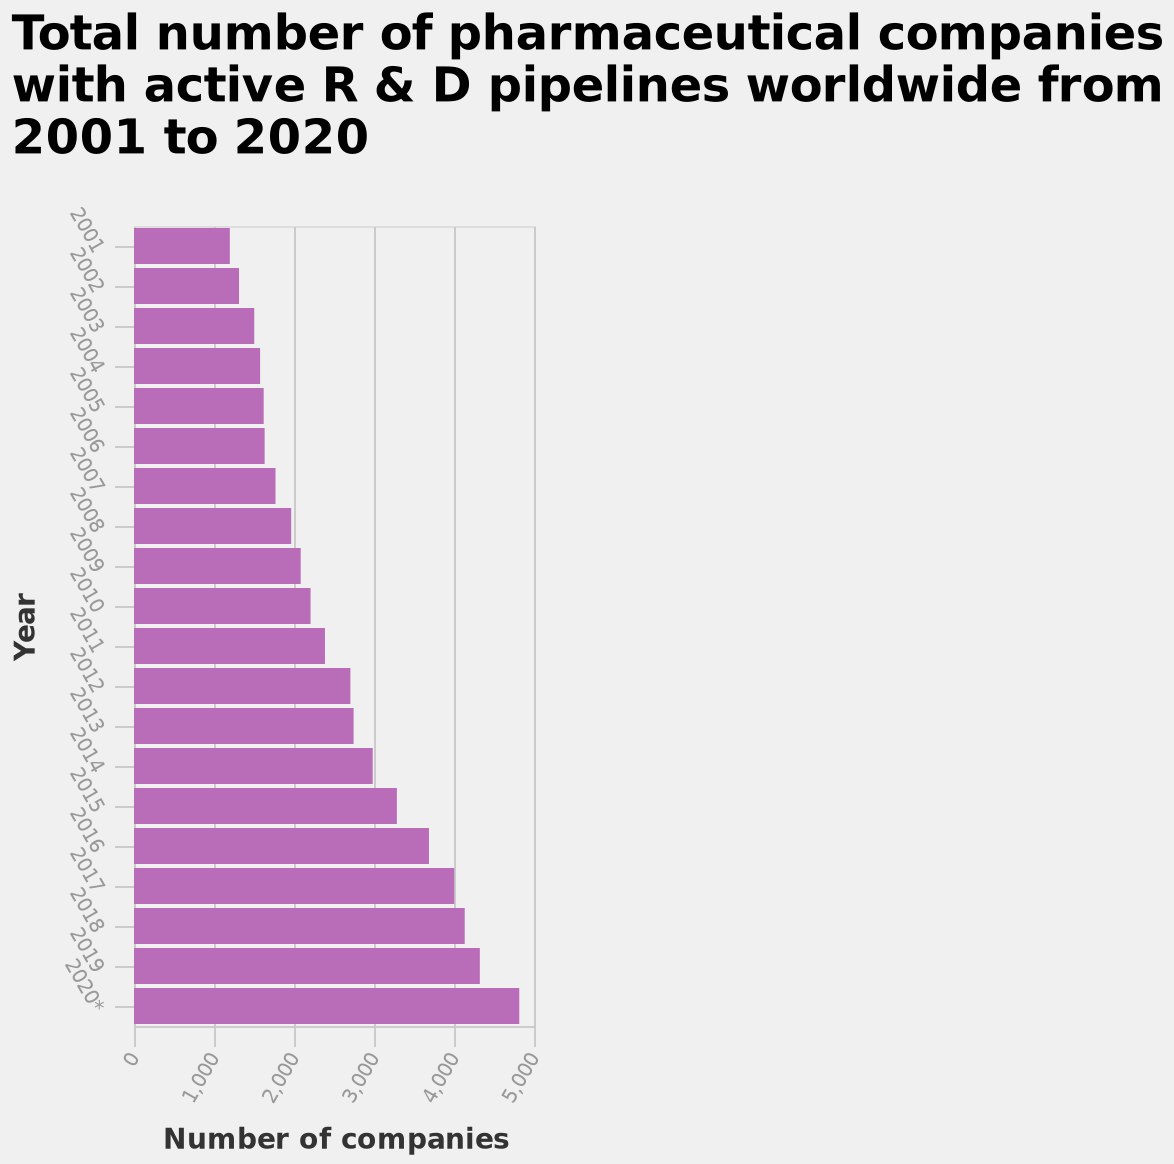<image>
How many pharmaceutical companies with active R & D pipelines worldwide were there in 2001?  The total number of pharmaceutical companies with active R & D pipelines worldwide in 2001 is shown on the x-axis of the bar graph. What is plotted on the x-axis of the bar graph? The number of companies is plotted on the x-axis of the bar graph. What is the trend in the number of companies with an active R&D pipeline over the years? The trend shows a significant increase in the number of companies with an active R&D pipeline between 2001-2020. 